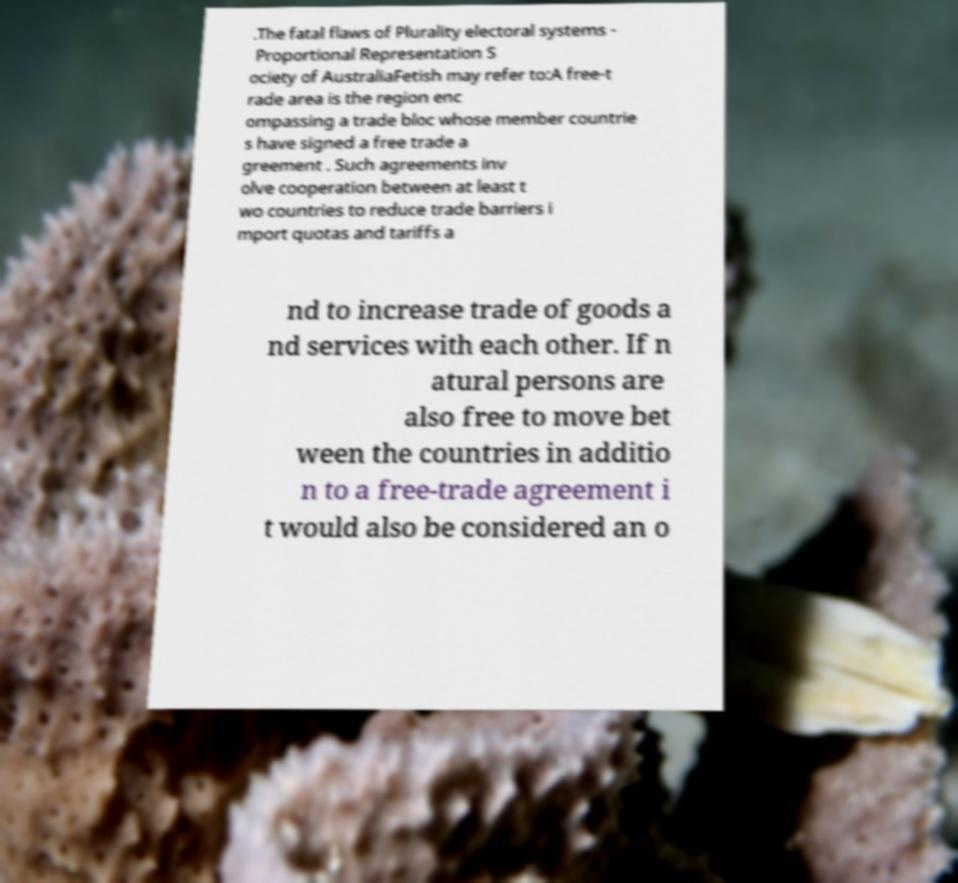Please read and relay the text visible in this image. What does it say? .The fatal flaws of Plurality electoral systems - Proportional Representation S ociety of AustraliaFetish may refer to:A free-t rade area is the region enc ompassing a trade bloc whose member countrie s have signed a free trade a greement . Such agreements inv olve cooperation between at least t wo countries to reduce trade barriers i mport quotas and tariffs a nd to increase trade of goods a nd services with each other. If n atural persons are also free to move bet ween the countries in additio n to a free-trade agreement i t would also be considered an o 